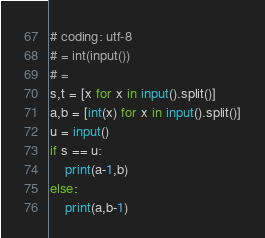Convert code to text. <code><loc_0><loc_0><loc_500><loc_500><_Python_># coding: utf-8
# = int(input())
# = 
s,t = [x for x in input().split()]
a,b = [int(x) for x in input().split()]
u = input()
if s == u:
    print(a-1,b)
else:
    print(a,b-1)</code> 